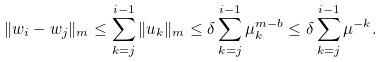<formula> <loc_0><loc_0><loc_500><loc_500>\| w _ { i } - w _ { j } \| _ { m } \leq \sum _ { k = j } ^ { i - 1 } \| u _ { k } \| _ { m } \leq \delta \sum _ { k = j } ^ { i - 1 } \mu _ { k } ^ { m - b } \leq \delta \sum _ { k = j } ^ { i - 1 } \mu ^ { - k } .</formula> 